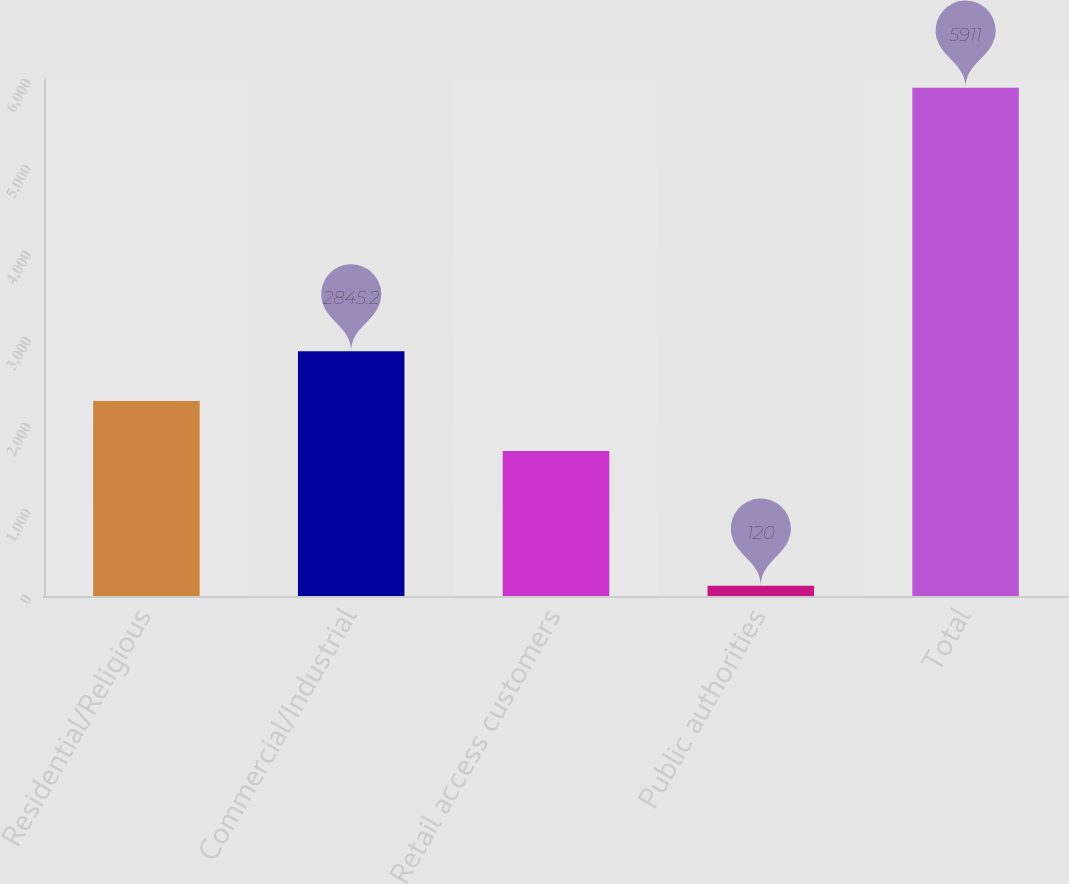Convert chart. <chart><loc_0><loc_0><loc_500><loc_500><bar_chart><fcel>Residential/Religious<fcel>Commercial/Industrial<fcel>Retail access customers<fcel>Public authorities<fcel>Total<nl><fcel>2266.1<fcel>2845.2<fcel>1687<fcel>120<fcel>5911<nl></chart> 